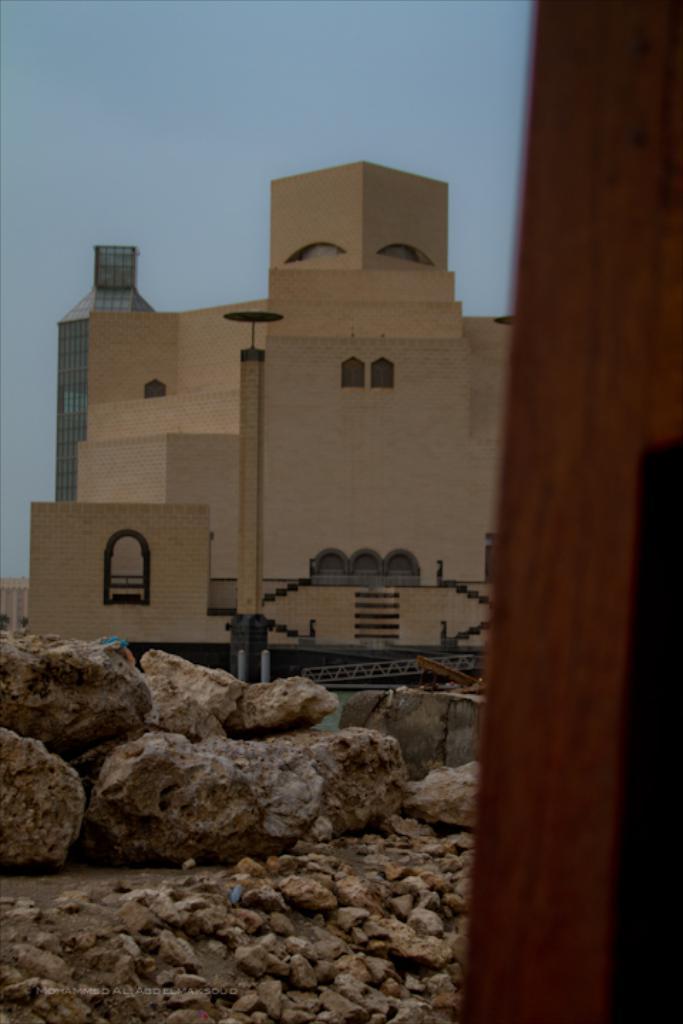How would you summarize this image in a sentence or two? In this image there are few stones, buildings, a tower, fence, a wooden object on the right side of the image and the sky. 